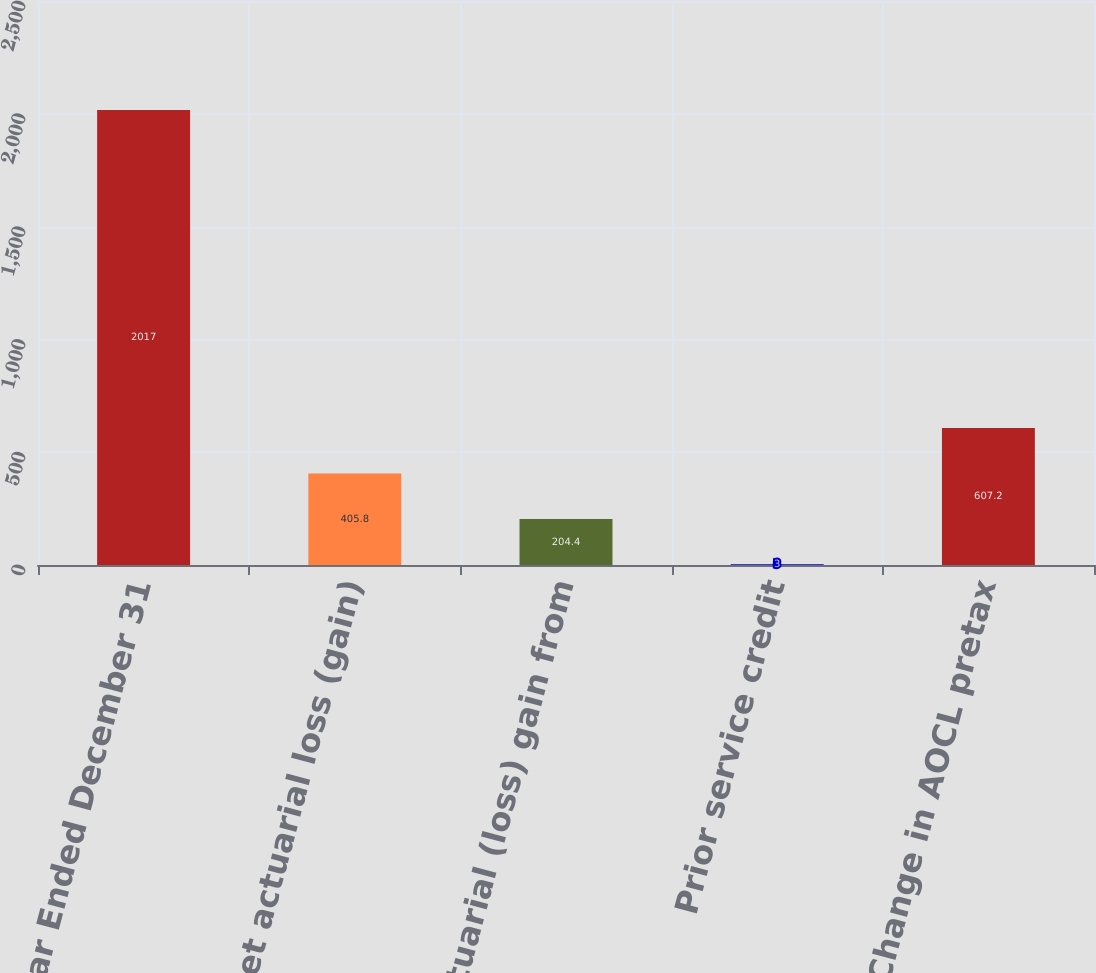Convert chart to OTSL. <chart><loc_0><loc_0><loc_500><loc_500><bar_chart><fcel>Year Ended December 31<fcel>Net actuarial loss (gain)<fcel>Net actuarial (loss) gain from<fcel>Prior service credit<fcel>Change in AOCL pretax<nl><fcel>2017<fcel>405.8<fcel>204.4<fcel>3<fcel>607.2<nl></chart> 